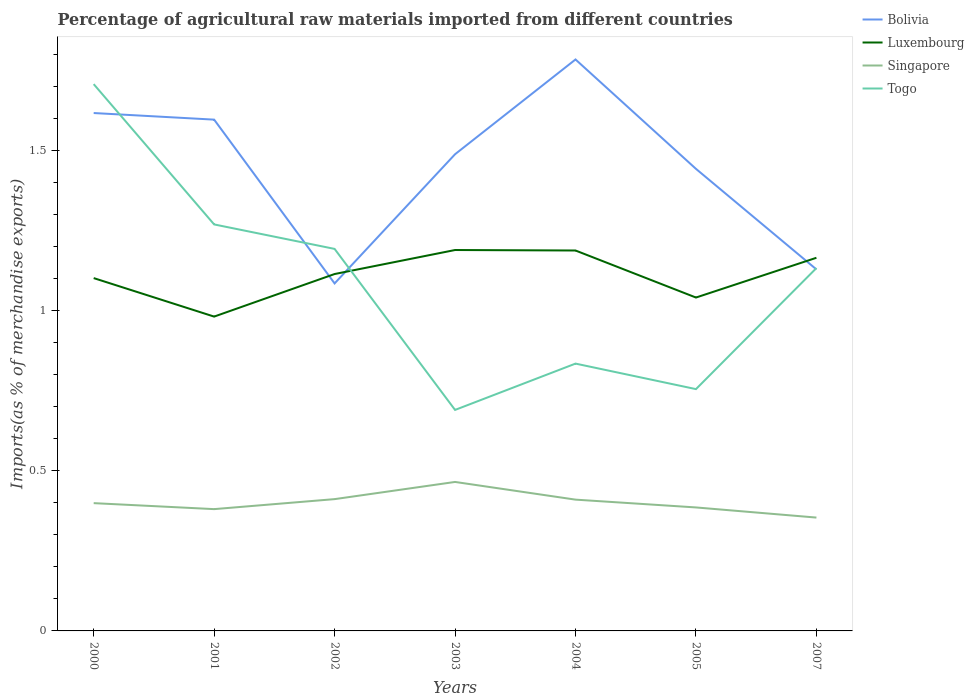Across all years, what is the maximum percentage of imports to different countries in Bolivia?
Provide a short and direct response. 1.09. What is the total percentage of imports to different countries in Luxembourg in the graph?
Offer a very short reply. -0.21. What is the difference between the highest and the second highest percentage of imports to different countries in Luxembourg?
Your answer should be compact. 0.21. Is the percentage of imports to different countries in Togo strictly greater than the percentage of imports to different countries in Bolivia over the years?
Keep it short and to the point. No. How many lines are there?
Provide a succinct answer. 4. What is the difference between two consecutive major ticks on the Y-axis?
Provide a succinct answer. 0.5. Are the values on the major ticks of Y-axis written in scientific E-notation?
Give a very brief answer. No. Does the graph contain any zero values?
Give a very brief answer. No. Does the graph contain grids?
Give a very brief answer. No. Where does the legend appear in the graph?
Your answer should be compact. Top right. How many legend labels are there?
Your answer should be compact. 4. What is the title of the graph?
Give a very brief answer. Percentage of agricultural raw materials imported from different countries. Does "Denmark" appear as one of the legend labels in the graph?
Offer a terse response. No. What is the label or title of the X-axis?
Your response must be concise. Years. What is the label or title of the Y-axis?
Make the answer very short. Imports(as % of merchandise exports). What is the Imports(as % of merchandise exports) of Bolivia in 2000?
Offer a very short reply. 1.62. What is the Imports(as % of merchandise exports) of Luxembourg in 2000?
Keep it short and to the point. 1.1. What is the Imports(as % of merchandise exports) of Singapore in 2000?
Provide a short and direct response. 0.4. What is the Imports(as % of merchandise exports) of Togo in 2000?
Give a very brief answer. 1.71. What is the Imports(as % of merchandise exports) of Bolivia in 2001?
Ensure brevity in your answer.  1.6. What is the Imports(as % of merchandise exports) of Luxembourg in 2001?
Your response must be concise. 0.98. What is the Imports(as % of merchandise exports) in Singapore in 2001?
Keep it short and to the point. 0.38. What is the Imports(as % of merchandise exports) of Togo in 2001?
Keep it short and to the point. 1.27. What is the Imports(as % of merchandise exports) in Bolivia in 2002?
Your answer should be compact. 1.09. What is the Imports(as % of merchandise exports) of Luxembourg in 2002?
Offer a terse response. 1.12. What is the Imports(as % of merchandise exports) of Singapore in 2002?
Provide a succinct answer. 0.41. What is the Imports(as % of merchandise exports) in Togo in 2002?
Your response must be concise. 1.19. What is the Imports(as % of merchandise exports) of Bolivia in 2003?
Give a very brief answer. 1.49. What is the Imports(as % of merchandise exports) in Luxembourg in 2003?
Keep it short and to the point. 1.19. What is the Imports(as % of merchandise exports) of Singapore in 2003?
Make the answer very short. 0.47. What is the Imports(as % of merchandise exports) in Togo in 2003?
Your answer should be very brief. 0.69. What is the Imports(as % of merchandise exports) in Bolivia in 2004?
Give a very brief answer. 1.79. What is the Imports(as % of merchandise exports) in Luxembourg in 2004?
Ensure brevity in your answer.  1.19. What is the Imports(as % of merchandise exports) of Singapore in 2004?
Your answer should be very brief. 0.41. What is the Imports(as % of merchandise exports) in Togo in 2004?
Offer a terse response. 0.84. What is the Imports(as % of merchandise exports) of Bolivia in 2005?
Your answer should be compact. 1.44. What is the Imports(as % of merchandise exports) in Luxembourg in 2005?
Keep it short and to the point. 1.04. What is the Imports(as % of merchandise exports) of Singapore in 2005?
Offer a very short reply. 0.39. What is the Imports(as % of merchandise exports) in Togo in 2005?
Provide a short and direct response. 0.76. What is the Imports(as % of merchandise exports) of Bolivia in 2007?
Your answer should be compact. 1.13. What is the Imports(as % of merchandise exports) in Luxembourg in 2007?
Offer a terse response. 1.17. What is the Imports(as % of merchandise exports) of Singapore in 2007?
Keep it short and to the point. 0.35. What is the Imports(as % of merchandise exports) of Togo in 2007?
Make the answer very short. 1.13. Across all years, what is the maximum Imports(as % of merchandise exports) in Bolivia?
Ensure brevity in your answer.  1.79. Across all years, what is the maximum Imports(as % of merchandise exports) of Luxembourg?
Make the answer very short. 1.19. Across all years, what is the maximum Imports(as % of merchandise exports) of Singapore?
Offer a terse response. 0.47. Across all years, what is the maximum Imports(as % of merchandise exports) of Togo?
Offer a very short reply. 1.71. Across all years, what is the minimum Imports(as % of merchandise exports) in Bolivia?
Provide a succinct answer. 1.09. Across all years, what is the minimum Imports(as % of merchandise exports) in Luxembourg?
Give a very brief answer. 0.98. Across all years, what is the minimum Imports(as % of merchandise exports) in Singapore?
Offer a terse response. 0.35. Across all years, what is the minimum Imports(as % of merchandise exports) of Togo?
Offer a terse response. 0.69. What is the total Imports(as % of merchandise exports) in Bolivia in the graph?
Your response must be concise. 10.15. What is the total Imports(as % of merchandise exports) of Luxembourg in the graph?
Offer a terse response. 7.79. What is the total Imports(as % of merchandise exports) of Singapore in the graph?
Your answer should be very brief. 2.81. What is the total Imports(as % of merchandise exports) in Togo in the graph?
Provide a short and direct response. 7.59. What is the difference between the Imports(as % of merchandise exports) of Bolivia in 2000 and that in 2001?
Offer a terse response. 0.02. What is the difference between the Imports(as % of merchandise exports) in Luxembourg in 2000 and that in 2001?
Keep it short and to the point. 0.12. What is the difference between the Imports(as % of merchandise exports) of Singapore in 2000 and that in 2001?
Provide a succinct answer. 0.02. What is the difference between the Imports(as % of merchandise exports) in Togo in 2000 and that in 2001?
Your answer should be very brief. 0.44. What is the difference between the Imports(as % of merchandise exports) of Bolivia in 2000 and that in 2002?
Provide a succinct answer. 0.53. What is the difference between the Imports(as % of merchandise exports) of Luxembourg in 2000 and that in 2002?
Your answer should be very brief. -0.01. What is the difference between the Imports(as % of merchandise exports) of Singapore in 2000 and that in 2002?
Provide a short and direct response. -0.01. What is the difference between the Imports(as % of merchandise exports) in Togo in 2000 and that in 2002?
Provide a short and direct response. 0.52. What is the difference between the Imports(as % of merchandise exports) of Bolivia in 2000 and that in 2003?
Provide a short and direct response. 0.13. What is the difference between the Imports(as % of merchandise exports) in Luxembourg in 2000 and that in 2003?
Make the answer very short. -0.09. What is the difference between the Imports(as % of merchandise exports) of Singapore in 2000 and that in 2003?
Provide a short and direct response. -0.07. What is the difference between the Imports(as % of merchandise exports) in Togo in 2000 and that in 2003?
Keep it short and to the point. 1.02. What is the difference between the Imports(as % of merchandise exports) of Bolivia in 2000 and that in 2004?
Provide a succinct answer. -0.17. What is the difference between the Imports(as % of merchandise exports) in Luxembourg in 2000 and that in 2004?
Make the answer very short. -0.09. What is the difference between the Imports(as % of merchandise exports) of Singapore in 2000 and that in 2004?
Give a very brief answer. -0.01. What is the difference between the Imports(as % of merchandise exports) in Togo in 2000 and that in 2004?
Provide a short and direct response. 0.87. What is the difference between the Imports(as % of merchandise exports) in Bolivia in 2000 and that in 2005?
Ensure brevity in your answer.  0.17. What is the difference between the Imports(as % of merchandise exports) of Luxembourg in 2000 and that in 2005?
Your response must be concise. 0.06. What is the difference between the Imports(as % of merchandise exports) in Singapore in 2000 and that in 2005?
Make the answer very short. 0.01. What is the difference between the Imports(as % of merchandise exports) of Togo in 2000 and that in 2005?
Offer a terse response. 0.95. What is the difference between the Imports(as % of merchandise exports) in Bolivia in 2000 and that in 2007?
Ensure brevity in your answer.  0.49. What is the difference between the Imports(as % of merchandise exports) of Luxembourg in 2000 and that in 2007?
Make the answer very short. -0.06. What is the difference between the Imports(as % of merchandise exports) of Singapore in 2000 and that in 2007?
Ensure brevity in your answer.  0.05. What is the difference between the Imports(as % of merchandise exports) in Togo in 2000 and that in 2007?
Offer a terse response. 0.57. What is the difference between the Imports(as % of merchandise exports) in Bolivia in 2001 and that in 2002?
Provide a succinct answer. 0.51. What is the difference between the Imports(as % of merchandise exports) of Luxembourg in 2001 and that in 2002?
Provide a short and direct response. -0.13. What is the difference between the Imports(as % of merchandise exports) in Singapore in 2001 and that in 2002?
Provide a short and direct response. -0.03. What is the difference between the Imports(as % of merchandise exports) of Togo in 2001 and that in 2002?
Offer a very short reply. 0.08. What is the difference between the Imports(as % of merchandise exports) of Bolivia in 2001 and that in 2003?
Make the answer very short. 0.11. What is the difference between the Imports(as % of merchandise exports) in Luxembourg in 2001 and that in 2003?
Give a very brief answer. -0.21. What is the difference between the Imports(as % of merchandise exports) in Singapore in 2001 and that in 2003?
Keep it short and to the point. -0.08. What is the difference between the Imports(as % of merchandise exports) of Togo in 2001 and that in 2003?
Offer a terse response. 0.58. What is the difference between the Imports(as % of merchandise exports) in Bolivia in 2001 and that in 2004?
Keep it short and to the point. -0.19. What is the difference between the Imports(as % of merchandise exports) of Luxembourg in 2001 and that in 2004?
Offer a very short reply. -0.21. What is the difference between the Imports(as % of merchandise exports) in Singapore in 2001 and that in 2004?
Offer a very short reply. -0.03. What is the difference between the Imports(as % of merchandise exports) of Togo in 2001 and that in 2004?
Provide a succinct answer. 0.43. What is the difference between the Imports(as % of merchandise exports) of Bolivia in 2001 and that in 2005?
Keep it short and to the point. 0.15. What is the difference between the Imports(as % of merchandise exports) of Luxembourg in 2001 and that in 2005?
Offer a very short reply. -0.06. What is the difference between the Imports(as % of merchandise exports) in Singapore in 2001 and that in 2005?
Offer a terse response. -0.01. What is the difference between the Imports(as % of merchandise exports) in Togo in 2001 and that in 2005?
Your response must be concise. 0.51. What is the difference between the Imports(as % of merchandise exports) of Bolivia in 2001 and that in 2007?
Give a very brief answer. 0.47. What is the difference between the Imports(as % of merchandise exports) of Luxembourg in 2001 and that in 2007?
Keep it short and to the point. -0.18. What is the difference between the Imports(as % of merchandise exports) of Singapore in 2001 and that in 2007?
Provide a short and direct response. 0.03. What is the difference between the Imports(as % of merchandise exports) of Togo in 2001 and that in 2007?
Offer a very short reply. 0.14. What is the difference between the Imports(as % of merchandise exports) in Bolivia in 2002 and that in 2003?
Provide a succinct answer. -0.4. What is the difference between the Imports(as % of merchandise exports) of Luxembourg in 2002 and that in 2003?
Make the answer very short. -0.07. What is the difference between the Imports(as % of merchandise exports) of Singapore in 2002 and that in 2003?
Keep it short and to the point. -0.05. What is the difference between the Imports(as % of merchandise exports) in Togo in 2002 and that in 2003?
Your answer should be very brief. 0.5. What is the difference between the Imports(as % of merchandise exports) in Bolivia in 2002 and that in 2004?
Offer a terse response. -0.7. What is the difference between the Imports(as % of merchandise exports) of Luxembourg in 2002 and that in 2004?
Make the answer very short. -0.07. What is the difference between the Imports(as % of merchandise exports) of Singapore in 2002 and that in 2004?
Provide a short and direct response. 0. What is the difference between the Imports(as % of merchandise exports) of Togo in 2002 and that in 2004?
Ensure brevity in your answer.  0.36. What is the difference between the Imports(as % of merchandise exports) in Bolivia in 2002 and that in 2005?
Your response must be concise. -0.36. What is the difference between the Imports(as % of merchandise exports) of Luxembourg in 2002 and that in 2005?
Ensure brevity in your answer.  0.07. What is the difference between the Imports(as % of merchandise exports) in Singapore in 2002 and that in 2005?
Give a very brief answer. 0.03. What is the difference between the Imports(as % of merchandise exports) in Togo in 2002 and that in 2005?
Offer a very short reply. 0.44. What is the difference between the Imports(as % of merchandise exports) of Bolivia in 2002 and that in 2007?
Keep it short and to the point. -0.04. What is the difference between the Imports(as % of merchandise exports) of Luxembourg in 2002 and that in 2007?
Make the answer very short. -0.05. What is the difference between the Imports(as % of merchandise exports) in Singapore in 2002 and that in 2007?
Make the answer very short. 0.06. What is the difference between the Imports(as % of merchandise exports) in Togo in 2002 and that in 2007?
Provide a short and direct response. 0.06. What is the difference between the Imports(as % of merchandise exports) of Bolivia in 2003 and that in 2004?
Offer a terse response. -0.3. What is the difference between the Imports(as % of merchandise exports) of Luxembourg in 2003 and that in 2004?
Offer a very short reply. 0. What is the difference between the Imports(as % of merchandise exports) of Singapore in 2003 and that in 2004?
Keep it short and to the point. 0.06. What is the difference between the Imports(as % of merchandise exports) in Togo in 2003 and that in 2004?
Ensure brevity in your answer.  -0.14. What is the difference between the Imports(as % of merchandise exports) of Bolivia in 2003 and that in 2005?
Give a very brief answer. 0.05. What is the difference between the Imports(as % of merchandise exports) of Luxembourg in 2003 and that in 2005?
Your response must be concise. 0.15. What is the difference between the Imports(as % of merchandise exports) of Singapore in 2003 and that in 2005?
Make the answer very short. 0.08. What is the difference between the Imports(as % of merchandise exports) in Togo in 2003 and that in 2005?
Give a very brief answer. -0.07. What is the difference between the Imports(as % of merchandise exports) of Bolivia in 2003 and that in 2007?
Offer a very short reply. 0.36. What is the difference between the Imports(as % of merchandise exports) in Luxembourg in 2003 and that in 2007?
Offer a very short reply. 0.02. What is the difference between the Imports(as % of merchandise exports) in Singapore in 2003 and that in 2007?
Make the answer very short. 0.11. What is the difference between the Imports(as % of merchandise exports) in Togo in 2003 and that in 2007?
Provide a short and direct response. -0.44. What is the difference between the Imports(as % of merchandise exports) in Bolivia in 2004 and that in 2005?
Your answer should be compact. 0.34. What is the difference between the Imports(as % of merchandise exports) of Luxembourg in 2004 and that in 2005?
Your response must be concise. 0.15. What is the difference between the Imports(as % of merchandise exports) of Singapore in 2004 and that in 2005?
Your answer should be compact. 0.02. What is the difference between the Imports(as % of merchandise exports) in Togo in 2004 and that in 2005?
Ensure brevity in your answer.  0.08. What is the difference between the Imports(as % of merchandise exports) of Bolivia in 2004 and that in 2007?
Make the answer very short. 0.66. What is the difference between the Imports(as % of merchandise exports) of Luxembourg in 2004 and that in 2007?
Give a very brief answer. 0.02. What is the difference between the Imports(as % of merchandise exports) in Singapore in 2004 and that in 2007?
Offer a terse response. 0.06. What is the difference between the Imports(as % of merchandise exports) of Togo in 2004 and that in 2007?
Your response must be concise. -0.3. What is the difference between the Imports(as % of merchandise exports) in Bolivia in 2005 and that in 2007?
Your answer should be compact. 0.31. What is the difference between the Imports(as % of merchandise exports) in Luxembourg in 2005 and that in 2007?
Offer a very short reply. -0.12. What is the difference between the Imports(as % of merchandise exports) of Singapore in 2005 and that in 2007?
Make the answer very short. 0.03. What is the difference between the Imports(as % of merchandise exports) in Togo in 2005 and that in 2007?
Keep it short and to the point. -0.38. What is the difference between the Imports(as % of merchandise exports) of Bolivia in 2000 and the Imports(as % of merchandise exports) of Luxembourg in 2001?
Make the answer very short. 0.64. What is the difference between the Imports(as % of merchandise exports) of Bolivia in 2000 and the Imports(as % of merchandise exports) of Singapore in 2001?
Offer a very short reply. 1.24. What is the difference between the Imports(as % of merchandise exports) of Bolivia in 2000 and the Imports(as % of merchandise exports) of Togo in 2001?
Make the answer very short. 0.35. What is the difference between the Imports(as % of merchandise exports) of Luxembourg in 2000 and the Imports(as % of merchandise exports) of Singapore in 2001?
Make the answer very short. 0.72. What is the difference between the Imports(as % of merchandise exports) in Luxembourg in 2000 and the Imports(as % of merchandise exports) in Togo in 2001?
Offer a very short reply. -0.17. What is the difference between the Imports(as % of merchandise exports) of Singapore in 2000 and the Imports(as % of merchandise exports) of Togo in 2001?
Provide a short and direct response. -0.87. What is the difference between the Imports(as % of merchandise exports) in Bolivia in 2000 and the Imports(as % of merchandise exports) in Luxembourg in 2002?
Make the answer very short. 0.5. What is the difference between the Imports(as % of merchandise exports) of Bolivia in 2000 and the Imports(as % of merchandise exports) of Singapore in 2002?
Provide a succinct answer. 1.21. What is the difference between the Imports(as % of merchandise exports) of Bolivia in 2000 and the Imports(as % of merchandise exports) of Togo in 2002?
Make the answer very short. 0.42. What is the difference between the Imports(as % of merchandise exports) in Luxembourg in 2000 and the Imports(as % of merchandise exports) in Singapore in 2002?
Provide a succinct answer. 0.69. What is the difference between the Imports(as % of merchandise exports) of Luxembourg in 2000 and the Imports(as % of merchandise exports) of Togo in 2002?
Your answer should be very brief. -0.09. What is the difference between the Imports(as % of merchandise exports) of Singapore in 2000 and the Imports(as % of merchandise exports) of Togo in 2002?
Ensure brevity in your answer.  -0.79. What is the difference between the Imports(as % of merchandise exports) of Bolivia in 2000 and the Imports(as % of merchandise exports) of Luxembourg in 2003?
Your response must be concise. 0.43. What is the difference between the Imports(as % of merchandise exports) in Bolivia in 2000 and the Imports(as % of merchandise exports) in Singapore in 2003?
Your answer should be compact. 1.15. What is the difference between the Imports(as % of merchandise exports) in Bolivia in 2000 and the Imports(as % of merchandise exports) in Togo in 2003?
Keep it short and to the point. 0.93. What is the difference between the Imports(as % of merchandise exports) of Luxembourg in 2000 and the Imports(as % of merchandise exports) of Singapore in 2003?
Give a very brief answer. 0.64. What is the difference between the Imports(as % of merchandise exports) of Luxembourg in 2000 and the Imports(as % of merchandise exports) of Togo in 2003?
Make the answer very short. 0.41. What is the difference between the Imports(as % of merchandise exports) of Singapore in 2000 and the Imports(as % of merchandise exports) of Togo in 2003?
Your response must be concise. -0.29. What is the difference between the Imports(as % of merchandise exports) of Bolivia in 2000 and the Imports(as % of merchandise exports) of Luxembourg in 2004?
Your response must be concise. 0.43. What is the difference between the Imports(as % of merchandise exports) of Bolivia in 2000 and the Imports(as % of merchandise exports) of Singapore in 2004?
Your answer should be very brief. 1.21. What is the difference between the Imports(as % of merchandise exports) in Bolivia in 2000 and the Imports(as % of merchandise exports) in Togo in 2004?
Provide a succinct answer. 0.78. What is the difference between the Imports(as % of merchandise exports) in Luxembourg in 2000 and the Imports(as % of merchandise exports) in Singapore in 2004?
Give a very brief answer. 0.69. What is the difference between the Imports(as % of merchandise exports) of Luxembourg in 2000 and the Imports(as % of merchandise exports) of Togo in 2004?
Your response must be concise. 0.27. What is the difference between the Imports(as % of merchandise exports) of Singapore in 2000 and the Imports(as % of merchandise exports) of Togo in 2004?
Your answer should be compact. -0.44. What is the difference between the Imports(as % of merchandise exports) of Bolivia in 2000 and the Imports(as % of merchandise exports) of Luxembourg in 2005?
Your response must be concise. 0.58. What is the difference between the Imports(as % of merchandise exports) of Bolivia in 2000 and the Imports(as % of merchandise exports) of Singapore in 2005?
Your response must be concise. 1.23. What is the difference between the Imports(as % of merchandise exports) of Bolivia in 2000 and the Imports(as % of merchandise exports) of Togo in 2005?
Your answer should be compact. 0.86. What is the difference between the Imports(as % of merchandise exports) of Luxembourg in 2000 and the Imports(as % of merchandise exports) of Singapore in 2005?
Ensure brevity in your answer.  0.72. What is the difference between the Imports(as % of merchandise exports) of Luxembourg in 2000 and the Imports(as % of merchandise exports) of Togo in 2005?
Ensure brevity in your answer.  0.35. What is the difference between the Imports(as % of merchandise exports) in Singapore in 2000 and the Imports(as % of merchandise exports) in Togo in 2005?
Offer a very short reply. -0.36. What is the difference between the Imports(as % of merchandise exports) of Bolivia in 2000 and the Imports(as % of merchandise exports) of Luxembourg in 2007?
Offer a terse response. 0.45. What is the difference between the Imports(as % of merchandise exports) of Bolivia in 2000 and the Imports(as % of merchandise exports) of Singapore in 2007?
Provide a short and direct response. 1.26. What is the difference between the Imports(as % of merchandise exports) in Bolivia in 2000 and the Imports(as % of merchandise exports) in Togo in 2007?
Provide a short and direct response. 0.48. What is the difference between the Imports(as % of merchandise exports) of Luxembourg in 2000 and the Imports(as % of merchandise exports) of Singapore in 2007?
Your response must be concise. 0.75. What is the difference between the Imports(as % of merchandise exports) in Luxembourg in 2000 and the Imports(as % of merchandise exports) in Togo in 2007?
Provide a succinct answer. -0.03. What is the difference between the Imports(as % of merchandise exports) in Singapore in 2000 and the Imports(as % of merchandise exports) in Togo in 2007?
Your answer should be very brief. -0.73. What is the difference between the Imports(as % of merchandise exports) in Bolivia in 2001 and the Imports(as % of merchandise exports) in Luxembourg in 2002?
Ensure brevity in your answer.  0.48. What is the difference between the Imports(as % of merchandise exports) in Bolivia in 2001 and the Imports(as % of merchandise exports) in Singapore in 2002?
Your answer should be compact. 1.19. What is the difference between the Imports(as % of merchandise exports) of Bolivia in 2001 and the Imports(as % of merchandise exports) of Togo in 2002?
Provide a short and direct response. 0.4. What is the difference between the Imports(as % of merchandise exports) of Luxembourg in 2001 and the Imports(as % of merchandise exports) of Singapore in 2002?
Keep it short and to the point. 0.57. What is the difference between the Imports(as % of merchandise exports) of Luxembourg in 2001 and the Imports(as % of merchandise exports) of Togo in 2002?
Your answer should be compact. -0.21. What is the difference between the Imports(as % of merchandise exports) in Singapore in 2001 and the Imports(as % of merchandise exports) in Togo in 2002?
Give a very brief answer. -0.81. What is the difference between the Imports(as % of merchandise exports) of Bolivia in 2001 and the Imports(as % of merchandise exports) of Luxembourg in 2003?
Provide a succinct answer. 0.41. What is the difference between the Imports(as % of merchandise exports) in Bolivia in 2001 and the Imports(as % of merchandise exports) in Singapore in 2003?
Give a very brief answer. 1.13. What is the difference between the Imports(as % of merchandise exports) of Bolivia in 2001 and the Imports(as % of merchandise exports) of Togo in 2003?
Your answer should be very brief. 0.91. What is the difference between the Imports(as % of merchandise exports) in Luxembourg in 2001 and the Imports(as % of merchandise exports) in Singapore in 2003?
Provide a short and direct response. 0.52. What is the difference between the Imports(as % of merchandise exports) in Luxembourg in 2001 and the Imports(as % of merchandise exports) in Togo in 2003?
Offer a very short reply. 0.29. What is the difference between the Imports(as % of merchandise exports) of Singapore in 2001 and the Imports(as % of merchandise exports) of Togo in 2003?
Make the answer very short. -0.31. What is the difference between the Imports(as % of merchandise exports) in Bolivia in 2001 and the Imports(as % of merchandise exports) in Luxembourg in 2004?
Provide a short and direct response. 0.41. What is the difference between the Imports(as % of merchandise exports) of Bolivia in 2001 and the Imports(as % of merchandise exports) of Singapore in 2004?
Offer a terse response. 1.19. What is the difference between the Imports(as % of merchandise exports) of Bolivia in 2001 and the Imports(as % of merchandise exports) of Togo in 2004?
Keep it short and to the point. 0.76. What is the difference between the Imports(as % of merchandise exports) of Luxembourg in 2001 and the Imports(as % of merchandise exports) of Singapore in 2004?
Provide a succinct answer. 0.57. What is the difference between the Imports(as % of merchandise exports) in Luxembourg in 2001 and the Imports(as % of merchandise exports) in Togo in 2004?
Your answer should be compact. 0.15. What is the difference between the Imports(as % of merchandise exports) in Singapore in 2001 and the Imports(as % of merchandise exports) in Togo in 2004?
Ensure brevity in your answer.  -0.45. What is the difference between the Imports(as % of merchandise exports) in Bolivia in 2001 and the Imports(as % of merchandise exports) in Luxembourg in 2005?
Your response must be concise. 0.56. What is the difference between the Imports(as % of merchandise exports) in Bolivia in 2001 and the Imports(as % of merchandise exports) in Singapore in 2005?
Offer a very short reply. 1.21. What is the difference between the Imports(as % of merchandise exports) in Bolivia in 2001 and the Imports(as % of merchandise exports) in Togo in 2005?
Make the answer very short. 0.84. What is the difference between the Imports(as % of merchandise exports) in Luxembourg in 2001 and the Imports(as % of merchandise exports) in Singapore in 2005?
Provide a short and direct response. 0.6. What is the difference between the Imports(as % of merchandise exports) in Luxembourg in 2001 and the Imports(as % of merchandise exports) in Togo in 2005?
Provide a succinct answer. 0.23. What is the difference between the Imports(as % of merchandise exports) of Singapore in 2001 and the Imports(as % of merchandise exports) of Togo in 2005?
Your answer should be very brief. -0.38. What is the difference between the Imports(as % of merchandise exports) in Bolivia in 2001 and the Imports(as % of merchandise exports) in Luxembourg in 2007?
Keep it short and to the point. 0.43. What is the difference between the Imports(as % of merchandise exports) of Bolivia in 2001 and the Imports(as % of merchandise exports) of Singapore in 2007?
Your response must be concise. 1.24. What is the difference between the Imports(as % of merchandise exports) of Bolivia in 2001 and the Imports(as % of merchandise exports) of Togo in 2007?
Offer a very short reply. 0.46. What is the difference between the Imports(as % of merchandise exports) in Luxembourg in 2001 and the Imports(as % of merchandise exports) in Singapore in 2007?
Make the answer very short. 0.63. What is the difference between the Imports(as % of merchandise exports) of Luxembourg in 2001 and the Imports(as % of merchandise exports) of Togo in 2007?
Your answer should be compact. -0.15. What is the difference between the Imports(as % of merchandise exports) of Singapore in 2001 and the Imports(as % of merchandise exports) of Togo in 2007?
Keep it short and to the point. -0.75. What is the difference between the Imports(as % of merchandise exports) of Bolivia in 2002 and the Imports(as % of merchandise exports) of Luxembourg in 2003?
Offer a very short reply. -0.1. What is the difference between the Imports(as % of merchandise exports) of Bolivia in 2002 and the Imports(as % of merchandise exports) of Singapore in 2003?
Offer a very short reply. 0.62. What is the difference between the Imports(as % of merchandise exports) of Bolivia in 2002 and the Imports(as % of merchandise exports) of Togo in 2003?
Keep it short and to the point. 0.4. What is the difference between the Imports(as % of merchandise exports) in Luxembourg in 2002 and the Imports(as % of merchandise exports) in Singapore in 2003?
Your response must be concise. 0.65. What is the difference between the Imports(as % of merchandise exports) of Luxembourg in 2002 and the Imports(as % of merchandise exports) of Togo in 2003?
Offer a very short reply. 0.42. What is the difference between the Imports(as % of merchandise exports) in Singapore in 2002 and the Imports(as % of merchandise exports) in Togo in 2003?
Your answer should be very brief. -0.28. What is the difference between the Imports(as % of merchandise exports) of Bolivia in 2002 and the Imports(as % of merchandise exports) of Luxembourg in 2004?
Provide a succinct answer. -0.1. What is the difference between the Imports(as % of merchandise exports) of Bolivia in 2002 and the Imports(as % of merchandise exports) of Singapore in 2004?
Provide a succinct answer. 0.68. What is the difference between the Imports(as % of merchandise exports) of Bolivia in 2002 and the Imports(as % of merchandise exports) of Togo in 2004?
Your response must be concise. 0.25. What is the difference between the Imports(as % of merchandise exports) in Luxembourg in 2002 and the Imports(as % of merchandise exports) in Singapore in 2004?
Make the answer very short. 0.71. What is the difference between the Imports(as % of merchandise exports) of Luxembourg in 2002 and the Imports(as % of merchandise exports) of Togo in 2004?
Your response must be concise. 0.28. What is the difference between the Imports(as % of merchandise exports) in Singapore in 2002 and the Imports(as % of merchandise exports) in Togo in 2004?
Your answer should be very brief. -0.42. What is the difference between the Imports(as % of merchandise exports) of Bolivia in 2002 and the Imports(as % of merchandise exports) of Luxembourg in 2005?
Give a very brief answer. 0.04. What is the difference between the Imports(as % of merchandise exports) in Bolivia in 2002 and the Imports(as % of merchandise exports) in Singapore in 2005?
Make the answer very short. 0.7. What is the difference between the Imports(as % of merchandise exports) in Bolivia in 2002 and the Imports(as % of merchandise exports) in Togo in 2005?
Provide a succinct answer. 0.33. What is the difference between the Imports(as % of merchandise exports) of Luxembourg in 2002 and the Imports(as % of merchandise exports) of Singapore in 2005?
Provide a short and direct response. 0.73. What is the difference between the Imports(as % of merchandise exports) in Luxembourg in 2002 and the Imports(as % of merchandise exports) in Togo in 2005?
Provide a short and direct response. 0.36. What is the difference between the Imports(as % of merchandise exports) in Singapore in 2002 and the Imports(as % of merchandise exports) in Togo in 2005?
Give a very brief answer. -0.34. What is the difference between the Imports(as % of merchandise exports) of Bolivia in 2002 and the Imports(as % of merchandise exports) of Luxembourg in 2007?
Keep it short and to the point. -0.08. What is the difference between the Imports(as % of merchandise exports) in Bolivia in 2002 and the Imports(as % of merchandise exports) in Singapore in 2007?
Provide a short and direct response. 0.73. What is the difference between the Imports(as % of merchandise exports) in Bolivia in 2002 and the Imports(as % of merchandise exports) in Togo in 2007?
Your answer should be very brief. -0.05. What is the difference between the Imports(as % of merchandise exports) of Luxembourg in 2002 and the Imports(as % of merchandise exports) of Singapore in 2007?
Make the answer very short. 0.76. What is the difference between the Imports(as % of merchandise exports) of Luxembourg in 2002 and the Imports(as % of merchandise exports) of Togo in 2007?
Offer a terse response. -0.02. What is the difference between the Imports(as % of merchandise exports) of Singapore in 2002 and the Imports(as % of merchandise exports) of Togo in 2007?
Ensure brevity in your answer.  -0.72. What is the difference between the Imports(as % of merchandise exports) of Bolivia in 2003 and the Imports(as % of merchandise exports) of Luxembourg in 2004?
Give a very brief answer. 0.3. What is the difference between the Imports(as % of merchandise exports) of Bolivia in 2003 and the Imports(as % of merchandise exports) of Singapore in 2004?
Keep it short and to the point. 1.08. What is the difference between the Imports(as % of merchandise exports) of Bolivia in 2003 and the Imports(as % of merchandise exports) of Togo in 2004?
Ensure brevity in your answer.  0.65. What is the difference between the Imports(as % of merchandise exports) in Luxembourg in 2003 and the Imports(as % of merchandise exports) in Singapore in 2004?
Keep it short and to the point. 0.78. What is the difference between the Imports(as % of merchandise exports) in Luxembourg in 2003 and the Imports(as % of merchandise exports) in Togo in 2004?
Provide a succinct answer. 0.35. What is the difference between the Imports(as % of merchandise exports) of Singapore in 2003 and the Imports(as % of merchandise exports) of Togo in 2004?
Give a very brief answer. -0.37. What is the difference between the Imports(as % of merchandise exports) of Bolivia in 2003 and the Imports(as % of merchandise exports) of Luxembourg in 2005?
Give a very brief answer. 0.45. What is the difference between the Imports(as % of merchandise exports) of Bolivia in 2003 and the Imports(as % of merchandise exports) of Singapore in 2005?
Provide a short and direct response. 1.1. What is the difference between the Imports(as % of merchandise exports) in Bolivia in 2003 and the Imports(as % of merchandise exports) in Togo in 2005?
Offer a very short reply. 0.73. What is the difference between the Imports(as % of merchandise exports) in Luxembourg in 2003 and the Imports(as % of merchandise exports) in Singapore in 2005?
Offer a very short reply. 0.8. What is the difference between the Imports(as % of merchandise exports) in Luxembourg in 2003 and the Imports(as % of merchandise exports) in Togo in 2005?
Your response must be concise. 0.43. What is the difference between the Imports(as % of merchandise exports) in Singapore in 2003 and the Imports(as % of merchandise exports) in Togo in 2005?
Your answer should be compact. -0.29. What is the difference between the Imports(as % of merchandise exports) of Bolivia in 2003 and the Imports(as % of merchandise exports) of Luxembourg in 2007?
Your response must be concise. 0.32. What is the difference between the Imports(as % of merchandise exports) of Bolivia in 2003 and the Imports(as % of merchandise exports) of Singapore in 2007?
Your answer should be very brief. 1.14. What is the difference between the Imports(as % of merchandise exports) of Bolivia in 2003 and the Imports(as % of merchandise exports) of Togo in 2007?
Your answer should be very brief. 0.36. What is the difference between the Imports(as % of merchandise exports) in Luxembourg in 2003 and the Imports(as % of merchandise exports) in Singapore in 2007?
Make the answer very short. 0.84. What is the difference between the Imports(as % of merchandise exports) in Luxembourg in 2003 and the Imports(as % of merchandise exports) in Togo in 2007?
Offer a very short reply. 0.06. What is the difference between the Imports(as % of merchandise exports) in Singapore in 2003 and the Imports(as % of merchandise exports) in Togo in 2007?
Your answer should be very brief. -0.67. What is the difference between the Imports(as % of merchandise exports) of Bolivia in 2004 and the Imports(as % of merchandise exports) of Luxembourg in 2005?
Keep it short and to the point. 0.74. What is the difference between the Imports(as % of merchandise exports) in Bolivia in 2004 and the Imports(as % of merchandise exports) in Singapore in 2005?
Make the answer very short. 1.4. What is the difference between the Imports(as % of merchandise exports) of Bolivia in 2004 and the Imports(as % of merchandise exports) of Togo in 2005?
Offer a terse response. 1.03. What is the difference between the Imports(as % of merchandise exports) in Luxembourg in 2004 and the Imports(as % of merchandise exports) in Singapore in 2005?
Your answer should be very brief. 0.8. What is the difference between the Imports(as % of merchandise exports) in Luxembourg in 2004 and the Imports(as % of merchandise exports) in Togo in 2005?
Your answer should be compact. 0.43. What is the difference between the Imports(as % of merchandise exports) of Singapore in 2004 and the Imports(as % of merchandise exports) of Togo in 2005?
Provide a succinct answer. -0.35. What is the difference between the Imports(as % of merchandise exports) of Bolivia in 2004 and the Imports(as % of merchandise exports) of Luxembourg in 2007?
Provide a short and direct response. 0.62. What is the difference between the Imports(as % of merchandise exports) of Bolivia in 2004 and the Imports(as % of merchandise exports) of Singapore in 2007?
Ensure brevity in your answer.  1.43. What is the difference between the Imports(as % of merchandise exports) of Bolivia in 2004 and the Imports(as % of merchandise exports) of Togo in 2007?
Make the answer very short. 0.65. What is the difference between the Imports(as % of merchandise exports) in Luxembourg in 2004 and the Imports(as % of merchandise exports) in Singapore in 2007?
Provide a succinct answer. 0.83. What is the difference between the Imports(as % of merchandise exports) in Luxembourg in 2004 and the Imports(as % of merchandise exports) in Togo in 2007?
Your response must be concise. 0.05. What is the difference between the Imports(as % of merchandise exports) in Singapore in 2004 and the Imports(as % of merchandise exports) in Togo in 2007?
Provide a succinct answer. -0.72. What is the difference between the Imports(as % of merchandise exports) of Bolivia in 2005 and the Imports(as % of merchandise exports) of Luxembourg in 2007?
Provide a short and direct response. 0.28. What is the difference between the Imports(as % of merchandise exports) of Bolivia in 2005 and the Imports(as % of merchandise exports) of Singapore in 2007?
Offer a very short reply. 1.09. What is the difference between the Imports(as % of merchandise exports) of Bolivia in 2005 and the Imports(as % of merchandise exports) of Togo in 2007?
Keep it short and to the point. 0.31. What is the difference between the Imports(as % of merchandise exports) in Luxembourg in 2005 and the Imports(as % of merchandise exports) in Singapore in 2007?
Your answer should be compact. 0.69. What is the difference between the Imports(as % of merchandise exports) of Luxembourg in 2005 and the Imports(as % of merchandise exports) of Togo in 2007?
Your answer should be very brief. -0.09. What is the difference between the Imports(as % of merchandise exports) in Singapore in 2005 and the Imports(as % of merchandise exports) in Togo in 2007?
Make the answer very short. -0.75. What is the average Imports(as % of merchandise exports) of Bolivia per year?
Provide a short and direct response. 1.45. What is the average Imports(as % of merchandise exports) of Luxembourg per year?
Ensure brevity in your answer.  1.11. What is the average Imports(as % of merchandise exports) in Singapore per year?
Give a very brief answer. 0.4. What is the average Imports(as % of merchandise exports) of Togo per year?
Give a very brief answer. 1.08. In the year 2000, what is the difference between the Imports(as % of merchandise exports) of Bolivia and Imports(as % of merchandise exports) of Luxembourg?
Offer a terse response. 0.52. In the year 2000, what is the difference between the Imports(as % of merchandise exports) in Bolivia and Imports(as % of merchandise exports) in Singapore?
Give a very brief answer. 1.22. In the year 2000, what is the difference between the Imports(as % of merchandise exports) of Bolivia and Imports(as % of merchandise exports) of Togo?
Your response must be concise. -0.09. In the year 2000, what is the difference between the Imports(as % of merchandise exports) of Luxembourg and Imports(as % of merchandise exports) of Singapore?
Your answer should be compact. 0.7. In the year 2000, what is the difference between the Imports(as % of merchandise exports) in Luxembourg and Imports(as % of merchandise exports) in Togo?
Provide a short and direct response. -0.61. In the year 2000, what is the difference between the Imports(as % of merchandise exports) in Singapore and Imports(as % of merchandise exports) in Togo?
Ensure brevity in your answer.  -1.31. In the year 2001, what is the difference between the Imports(as % of merchandise exports) in Bolivia and Imports(as % of merchandise exports) in Luxembourg?
Ensure brevity in your answer.  0.62. In the year 2001, what is the difference between the Imports(as % of merchandise exports) of Bolivia and Imports(as % of merchandise exports) of Singapore?
Offer a terse response. 1.22. In the year 2001, what is the difference between the Imports(as % of merchandise exports) of Bolivia and Imports(as % of merchandise exports) of Togo?
Give a very brief answer. 0.33. In the year 2001, what is the difference between the Imports(as % of merchandise exports) in Luxembourg and Imports(as % of merchandise exports) in Singapore?
Give a very brief answer. 0.6. In the year 2001, what is the difference between the Imports(as % of merchandise exports) of Luxembourg and Imports(as % of merchandise exports) of Togo?
Your answer should be very brief. -0.29. In the year 2001, what is the difference between the Imports(as % of merchandise exports) in Singapore and Imports(as % of merchandise exports) in Togo?
Offer a terse response. -0.89. In the year 2002, what is the difference between the Imports(as % of merchandise exports) of Bolivia and Imports(as % of merchandise exports) of Luxembourg?
Your answer should be very brief. -0.03. In the year 2002, what is the difference between the Imports(as % of merchandise exports) in Bolivia and Imports(as % of merchandise exports) in Singapore?
Offer a terse response. 0.67. In the year 2002, what is the difference between the Imports(as % of merchandise exports) of Bolivia and Imports(as % of merchandise exports) of Togo?
Provide a short and direct response. -0.11. In the year 2002, what is the difference between the Imports(as % of merchandise exports) in Luxembourg and Imports(as % of merchandise exports) in Singapore?
Give a very brief answer. 0.7. In the year 2002, what is the difference between the Imports(as % of merchandise exports) in Luxembourg and Imports(as % of merchandise exports) in Togo?
Give a very brief answer. -0.08. In the year 2002, what is the difference between the Imports(as % of merchandise exports) of Singapore and Imports(as % of merchandise exports) of Togo?
Your answer should be very brief. -0.78. In the year 2003, what is the difference between the Imports(as % of merchandise exports) in Bolivia and Imports(as % of merchandise exports) in Luxembourg?
Give a very brief answer. 0.3. In the year 2003, what is the difference between the Imports(as % of merchandise exports) in Bolivia and Imports(as % of merchandise exports) in Singapore?
Provide a succinct answer. 1.02. In the year 2003, what is the difference between the Imports(as % of merchandise exports) in Bolivia and Imports(as % of merchandise exports) in Togo?
Provide a succinct answer. 0.8. In the year 2003, what is the difference between the Imports(as % of merchandise exports) in Luxembourg and Imports(as % of merchandise exports) in Singapore?
Your answer should be very brief. 0.72. In the year 2003, what is the difference between the Imports(as % of merchandise exports) of Luxembourg and Imports(as % of merchandise exports) of Togo?
Offer a very short reply. 0.5. In the year 2003, what is the difference between the Imports(as % of merchandise exports) in Singapore and Imports(as % of merchandise exports) in Togo?
Make the answer very short. -0.23. In the year 2004, what is the difference between the Imports(as % of merchandise exports) in Bolivia and Imports(as % of merchandise exports) in Luxembourg?
Keep it short and to the point. 0.6. In the year 2004, what is the difference between the Imports(as % of merchandise exports) in Bolivia and Imports(as % of merchandise exports) in Singapore?
Your answer should be very brief. 1.38. In the year 2004, what is the difference between the Imports(as % of merchandise exports) of Bolivia and Imports(as % of merchandise exports) of Togo?
Give a very brief answer. 0.95. In the year 2004, what is the difference between the Imports(as % of merchandise exports) in Luxembourg and Imports(as % of merchandise exports) in Singapore?
Give a very brief answer. 0.78. In the year 2004, what is the difference between the Imports(as % of merchandise exports) of Luxembourg and Imports(as % of merchandise exports) of Togo?
Provide a short and direct response. 0.35. In the year 2004, what is the difference between the Imports(as % of merchandise exports) in Singapore and Imports(as % of merchandise exports) in Togo?
Your answer should be very brief. -0.43. In the year 2005, what is the difference between the Imports(as % of merchandise exports) in Bolivia and Imports(as % of merchandise exports) in Luxembourg?
Keep it short and to the point. 0.4. In the year 2005, what is the difference between the Imports(as % of merchandise exports) of Bolivia and Imports(as % of merchandise exports) of Singapore?
Your answer should be compact. 1.06. In the year 2005, what is the difference between the Imports(as % of merchandise exports) of Bolivia and Imports(as % of merchandise exports) of Togo?
Your answer should be very brief. 0.69. In the year 2005, what is the difference between the Imports(as % of merchandise exports) of Luxembourg and Imports(as % of merchandise exports) of Singapore?
Ensure brevity in your answer.  0.66. In the year 2005, what is the difference between the Imports(as % of merchandise exports) in Luxembourg and Imports(as % of merchandise exports) in Togo?
Offer a very short reply. 0.29. In the year 2005, what is the difference between the Imports(as % of merchandise exports) of Singapore and Imports(as % of merchandise exports) of Togo?
Make the answer very short. -0.37. In the year 2007, what is the difference between the Imports(as % of merchandise exports) in Bolivia and Imports(as % of merchandise exports) in Luxembourg?
Provide a short and direct response. -0.04. In the year 2007, what is the difference between the Imports(as % of merchandise exports) in Bolivia and Imports(as % of merchandise exports) in Singapore?
Your answer should be very brief. 0.78. In the year 2007, what is the difference between the Imports(as % of merchandise exports) of Bolivia and Imports(as % of merchandise exports) of Togo?
Offer a terse response. -0. In the year 2007, what is the difference between the Imports(as % of merchandise exports) of Luxembourg and Imports(as % of merchandise exports) of Singapore?
Provide a succinct answer. 0.81. In the year 2007, what is the difference between the Imports(as % of merchandise exports) in Luxembourg and Imports(as % of merchandise exports) in Togo?
Give a very brief answer. 0.03. In the year 2007, what is the difference between the Imports(as % of merchandise exports) in Singapore and Imports(as % of merchandise exports) in Togo?
Your response must be concise. -0.78. What is the ratio of the Imports(as % of merchandise exports) in Bolivia in 2000 to that in 2001?
Give a very brief answer. 1.01. What is the ratio of the Imports(as % of merchandise exports) of Luxembourg in 2000 to that in 2001?
Your answer should be compact. 1.12. What is the ratio of the Imports(as % of merchandise exports) of Singapore in 2000 to that in 2001?
Make the answer very short. 1.05. What is the ratio of the Imports(as % of merchandise exports) of Togo in 2000 to that in 2001?
Your answer should be very brief. 1.35. What is the ratio of the Imports(as % of merchandise exports) in Bolivia in 2000 to that in 2002?
Make the answer very short. 1.49. What is the ratio of the Imports(as % of merchandise exports) of Singapore in 2000 to that in 2002?
Make the answer very short. 0.97. What is the ratio of the Imports(as % of merchandise exports) in Togo in 2000 to that in 2002?
Provide a short and direct response. 1.43. What is the ratio of the Imports(as % of merchandise exports) in Bolivia in 2000 to that in 2003?
Your answer should be compact. 1.09. What is the ratio of the Imports(as % of merchandise exports) of Luxembourg in 2000 to that in 2003?
Keep it short and to the point. 0.93. What is the ratio of the Imports(as % of merchandise exports) of Singapore in 2000 to that in 2003?
Keep it short and to the point. 0.86. What is the ratio of the Imports(as % of merchandise exports) in Togo in 2000 to that in 2003?
Your answer should be very brief. 2.47. What is the ratio of the Imports(as % of merchandise exports) in Bolivia in 2000 to that in 2004?
Make the answer very short. 0.91. What is the ratio of the Imports(as % of merchandise exports) of Luxembourg in 2000 to that in 2004?
Keep it short and to the point. 0.93. What is the ratio of the Imports(as % of merchandise exports) in Singapore in 2000 to that in 2004?
Ensure brevity in your answer.  0.97. What is the ratio of the Imports(as % of merchandise exports) of Togo in 2000 to that in 2004?
Make the answer very short. 2.05. What is the ratio of the Imports(as % of merchandise exports) of Bolivia in 2000 to that in 2005?
Give a very brief answer. 1.12. What is the ratio of the Imports(as % of merchandise exports) of Luxembourg in 2000 to that in 2005?
Make the answer very short. 1.06. What is the ratio of the Imports(as % of merchandise exports) of Singapore in 2000 to that in 2005?
Ensure brevity in your answer.  1.03. What is the ratio of the Imports(as % of merchandise exports) of Togo in 2000 to that in 2005?
Ensure brevity in your answer.  2.26. What is the ratio of the Imports(as % of merchandise exports) of Bolivia in 2000 to that in 2007?
Your answer should be compact. 1.43. What is the ratio of the Imports(as % of merchandise exports) of Luxembourg in 2000 to that in 2007?
Provide a succinct answer. 0.95. What is the ratio of the Imports(as % of merchandise exports) in Singapore in 2000 to that in 2007?
Your answer should be compact. 1.13. What is the ratio of the Imports(as % of merchandise exports) in Togo in 2000 to that in 2007?
Your answer should be compact. 1.51. What is the ratio of the Imports(as % of merchandise exports) of Bolivia in 2001 to that in 2002?
Provide a short and direct response. 1.47. What is the ratio of the Imports(as % of merchandise exports) of Luxembourg in 2001 to that in 2002?
Offer a very short reply. 0.88. What is the ratio of the Imports(as % of merchandise exports) of Singapore in 2001 to that in 2002?
Offer a terse response. 0.92. What is the ratio of the Imports(as % of merchandise exports) of Togo in 2001 to that in 2002?
Your answer should be very brief. 1.06. What is the ratio of the Imports(as % of merchandise exports) in Bolivia in 2001 to that in 2003?
Offer a very short reply. 1.07. What is the ratio of the Imports(as % of merchandise exports) of Luxembourg in 2001 to that in 2003?
Provide a succinct answer. 0.83. What is the ratio of the Imports(as % of merchandise exports) of Singapore in 2001 to that in 2003?
Give a very brief answer. 0.82. What is the ratio of the Imports(as % of merchandise exports) in Togo in 2001 to that in 2003?
Your response must be concise. 1.84. What is the ratio of the Imports(as % of merchandise exports) in Bolivia in 2001 to that in 2004?
Make the answer very short. 0.89. What is the ratio of the Imports(as % of merchandise exports) of Luxembourg in 2001 to that in 2004?
Your answer should be compact. 0.83. What is the ratio of the Imports(as % of merchandise exports) of Singapore in 2001 to that in 2004?
Make the answer very short. 0.93. What is the ratio of the Imports(as % of merchandise exports) of Togo in 2001 to that in 2004?
Ensure brevity in your answer.  1.52. What is the ratio of the Imports(as % of merchandise exports) of Bolivia in 2001 to that in 2005?
Your answer should be compact. 1.11. What is the ratio of the Imports(as % of merchandise exports) of Luxembourg in 2001 to that in 2005?
Give a very brief answer. 0.94. What is the ratio of the Imports(as % of merchandise exports) in Singapore in 2001 to that in 2005?
Provide a short and direct response. 0.99. What is the ratio of the Imports(as % of merchandise exports) of Togo in 2001 to that in 2005?
Ensure brevity in your answer.  1.68. What is the ratio of the Imports(as % of merchandise exports) in Bolivia in 2001 to that in 2007?
Provide a succinct answer. 1.41. What is the ratio of the Imports(as % of merchandise exports) in Luxembourg in 2001 to that in 2007?
Your answer should be very brief. 0.84. What is the ratio of the Imports(as % of merchandise exports) of Singapore in 2001 to that in 2007?
Provide a succinct answer. 1.07. What is the ratio of the Imports(as % of merchandise exports) of Togo in 2001 to that in 2007?
Your answer should be very brief. 1.12. What is the ratio of the Imports(as % of merchandise exports) in Bolivia in 2002 to that in 2003?
Make the answer very short. 0.73. What is the ratio of the Imports(as % of merchandise exports) in Luxembourg in 2002 to that in 2003?
Provide a succinct answer. 0.94. What is the ratio of the Imports(as % of merchandise exports) in Singapore in 2002 to that in 2003?
Provide a short and direct response. 0.88. What is the ratio of the Imports(as % of merchandise exports) in Togo in 2002 to that in 2003?
Provide a succinct answer. 1.73. What is the ratio of the Imports(as % of merchandise exports) in Bolivia in 2002 to that in 2004?
Your response must be concise. 0.61. What is the ratio of the Imports(as % of merchandise exports) of Luxembourg in 2002 to that in 2004?
Keep it short and to the point. 0.94. What is the ratio of the Imports(as % of merchandise exports) of Singapore in 2002 to that in 2004?
Offer a very short reply. 1. What is the ratio of the Imports(as % of merchandise exports) in Togo in 2002 to that in 2004?
Offer a terse response. 1.43. What is the ratio of the Imports(as % of merchandise exports) of Bolivia in 2002 to that in 2005?
Your response must be concise. 0.75. What is the ratio of the Imports(as % of merchandise exports) in Luxembourg in 2002 to that in 2005?
Give a very brief answer. 1.07. What is the ratio of the Imports(as % of merchandise exports) in Singapore in 2002 to that in 2005?
Offer a very short reply. 1.07. What is the ratio of the Imports(as % of merchandise exports) of Togo in 2002 to that in 2005?
Provide a succinct answer. 1.58. What is the ratio of the Imports(as % of merchandise exports) in Bolivia in 2002 to that in 2007?
Make the answer very short. 0.96. What is the ratio of the Imports(as % of merchandise exports) in Luxembourg in 2002 to that in 2007?
Your answer should be compact. 0.96. What is the ratio of the Imports(as % of merchandise exports) of Singapore in 2002 to that in 2007?
Make the answer very short. 1.16. What is the ratio of the Imports(as % of merchandise exports) in Togo in 2002 to that in 2007?
Provide a succinct answer. 1.05. What is the ratio of the Imports(as % of merchandise exports) of Bolivia in 2003 to that in 2004?
Your answer should be very brief. 0.83. What is the ratio of the Imports(as % of merchandise exports) of Luxembourg in 2003 to that in 2004?
Offer a terse response. 1. What is the ratio of the Imports(as % of merchandise exports) of Singapore in 2003 to that in 2004?
Ensure brevity in your answer.  1.13. What is the ratio of the Imports(as % of merchandise exports) in Togo in 2003 to that in 2004?
Your answer should be compact. 0.83. What is the ratio of the Imports(as % of merchandise exports) in Bolivia in 2003 to that in 2005?
Make the answer very short. 1.03. What is the ratio of the Imports(as % of merchandise exports) of Luxembourg in 2003 to that in 2005?
Your response must be concise. 1.14. What is the ratio of the Imports(as % of merchandise exports) in Singapore in 2003 to that in 2005?
Give a very brief answer. 1.21. What is the ratio of the Imports(as % of merchandise exports) in Togo in 2003 to that in 2005?
Your response must be concise. 0.91. What is the ratio of the Imports(as % of merchandise exports) of Bolivia in 2003 to that in 2007?
Your answer should be very brief. 1.32. What is the ratio of the Imports(as % of merchandise exports) of Luxembourg in 2003 to that in 2007?
Ensure brevity in your answer.  1.02. What is the ratio of the Imports(as % of merchandise exports) in Singapore in 2003 to that in 2007?
Give a very brief answer. 1.31. What is the ratio of the Imports(as % of merchandise exports) in Togo in 2003 to that in 2007?
Ensure brevity in your answer.  0.61. What is the ratio of the Imports(as % of merchandise exports) in Bolivia in 2004 to that in 2005?
Keep it short and to the point. 1.24. What is the ratio of the Imports(as % of merchandise exports) of Luxembourg in 2004 to that in 2005?
Your response must be concise. 1.14. What is the ratio of the Imports(as % of merchandise exports) of Singapore in 2004 to that in 2005?
Ensure brevity in your answer.  1.06. What is the ratio of the Imports(as % of merchandise exports) of Togo in 2004 to that in 2005?
Provide a short and direct response. 1.11. What is the ratio of the Imports(as % of merchandise exports) of Bolivia in 2004 to that in 2007?
Offer a terse response. 1.58. What is the ratio of the Imports(as % of merchandise exports) in Luxembourg in 2004 to that in 2007?
Provide a short and direct response. 1.02. What is the ratio of the Imports(as % of merchandise exports) of Singapore in 2004 to that in 2007?
Keep it short and to the point. 1.16. What is the ratio of the Imports(as % of merchandise exports) in Togo in 2004 to that in 2007?
Provide a short and direct response. 0.74. What is the ratio of the Imports(as % of merchandise exports) in Bolivia in 2005 to that in 2007?
Your answer should be compact. 1.28. What is the ratio of the Imports(as % of merchandise exports) of Luxembourg in 2005 to that in 2007?
Make the answer very short. 0.89. What is the ratio of the Imports(as % of merchandise exports) of Singapore in 2005 to that in 2007?
Make the answer very short. 1.09. What is the ratio of the Imports(as % of merchandise exports) in Togo in 2005 to that in 2007?
Provide a succinct answer. 0.67. What is the difference between the highest and the second highest Imports(as % of merchandise exports) in Bolivia?
Make the answer very short. 0.17. What is the difference between the highest and the second highest Imports(as % of merchandise exports) of Luxembourg?
Give a very brief answer. 0. What is the difference between the highest and the second highest Imports(as % of merchandise exports) of Singapore?
Give a very brief answer. 0.05. What is the difference between the highest and the second highest Imports(as % of merchandise exports) of Togo?
Offer a very short reply. 0.44. What is the difference between the highest and the lowest Imports(as % of merchandise exports) in Bolivia?
Provide a short and direct response. 0.7. What is the difference between the highest and the lowest Imports(as % of merchandise exports) of Luxembourg?
Offer a terse response. 0.21. What is the difference between the highest and the lowest Imports(as % of merchandise exports) in Singapore?
Your response must be concise. 0.11. What is the difference between the highest and the lowest Imports(as % of merchandise exports) of Togo?
Make the answer very short. 1.02. 